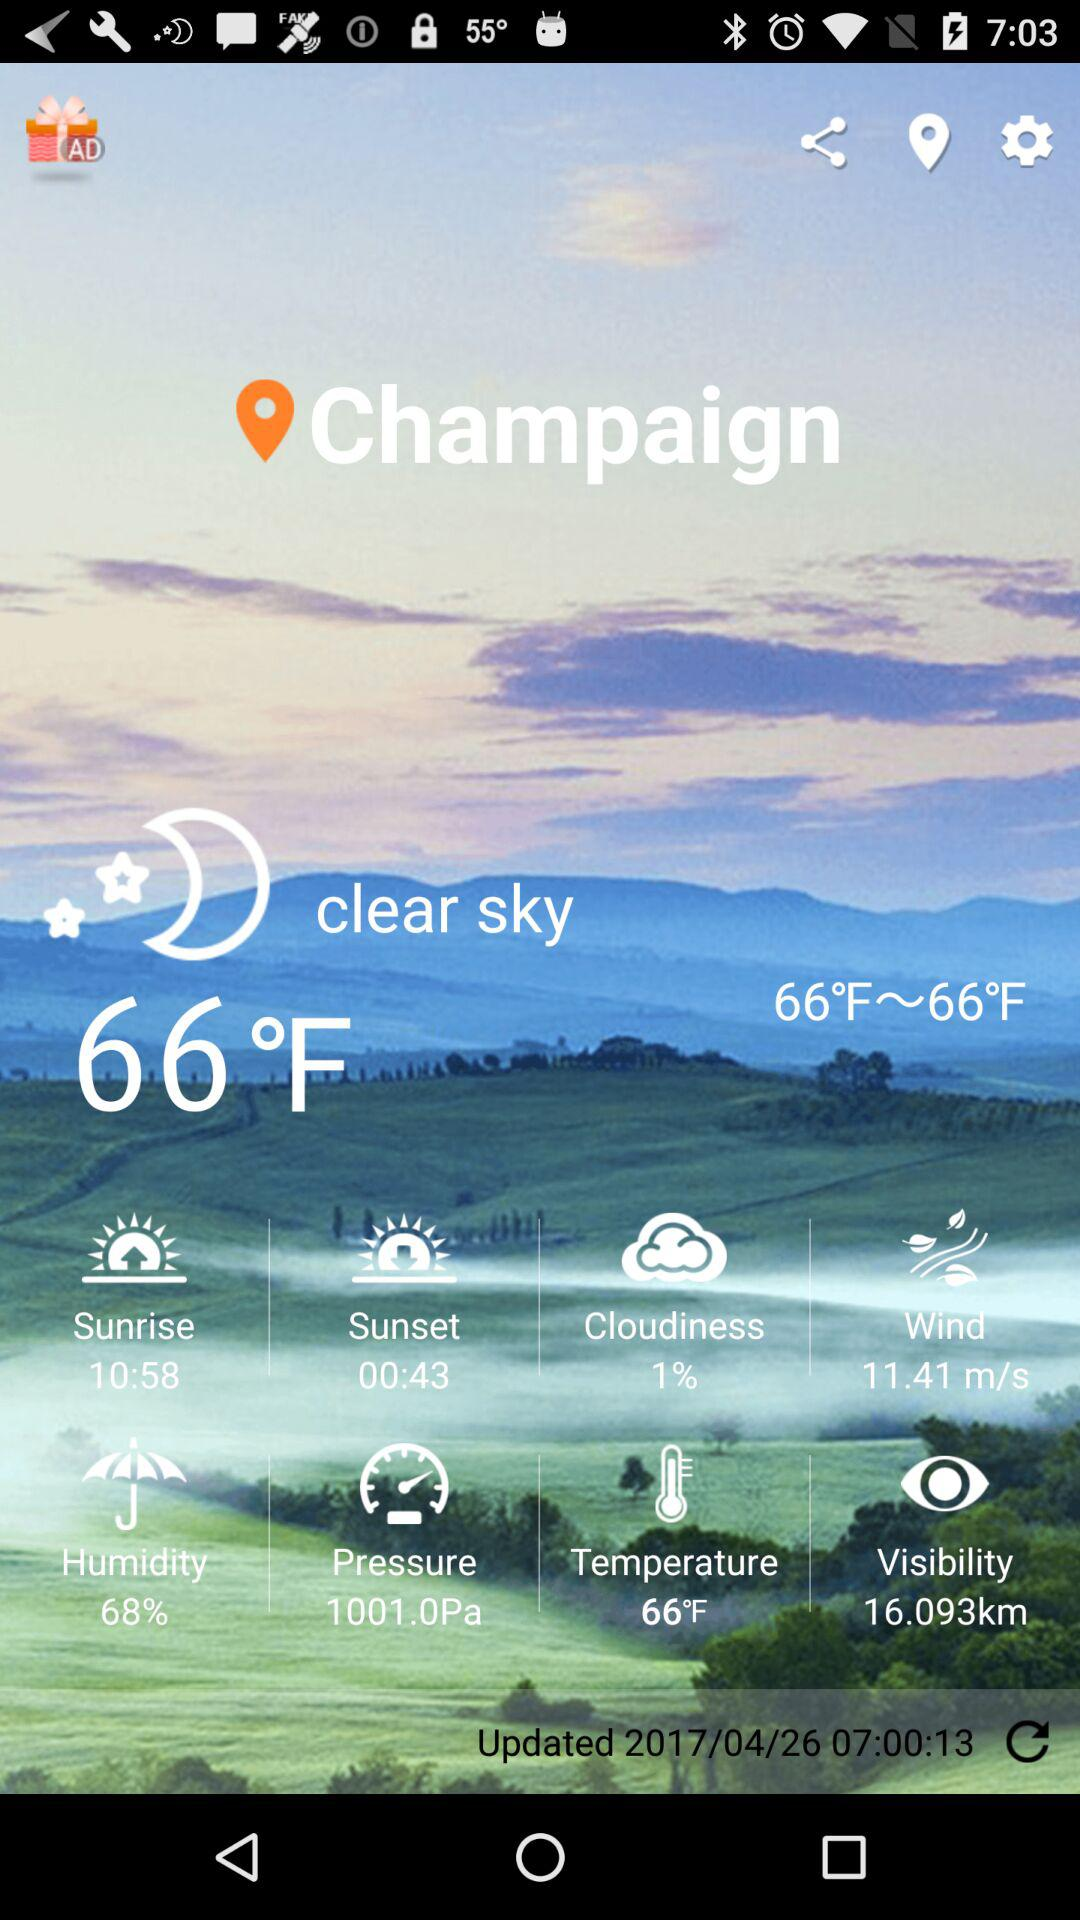What is the sunrise time? The sunrise time is 10:58. 